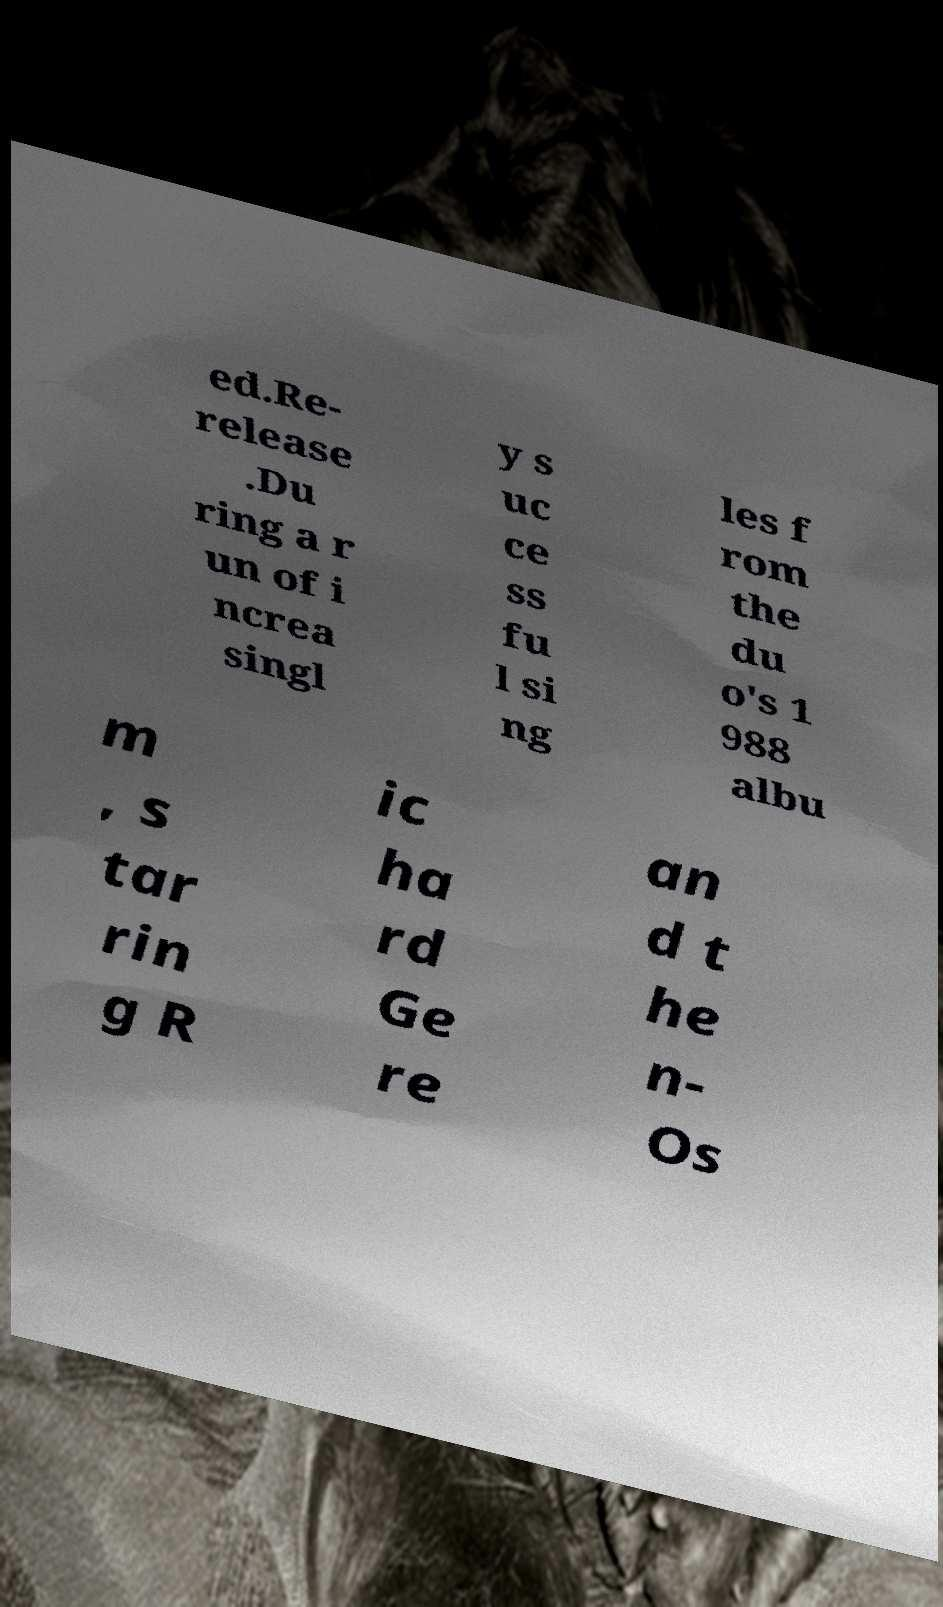Could you extract and type out the text from this image? ed.Re- release .Du ring a r un of i ncrea singl y s uc ce ss fu l si ng les f rom the du o's 1 988 albu m , s tar rin g R ic ha rd Ge re an d t he n- Os 